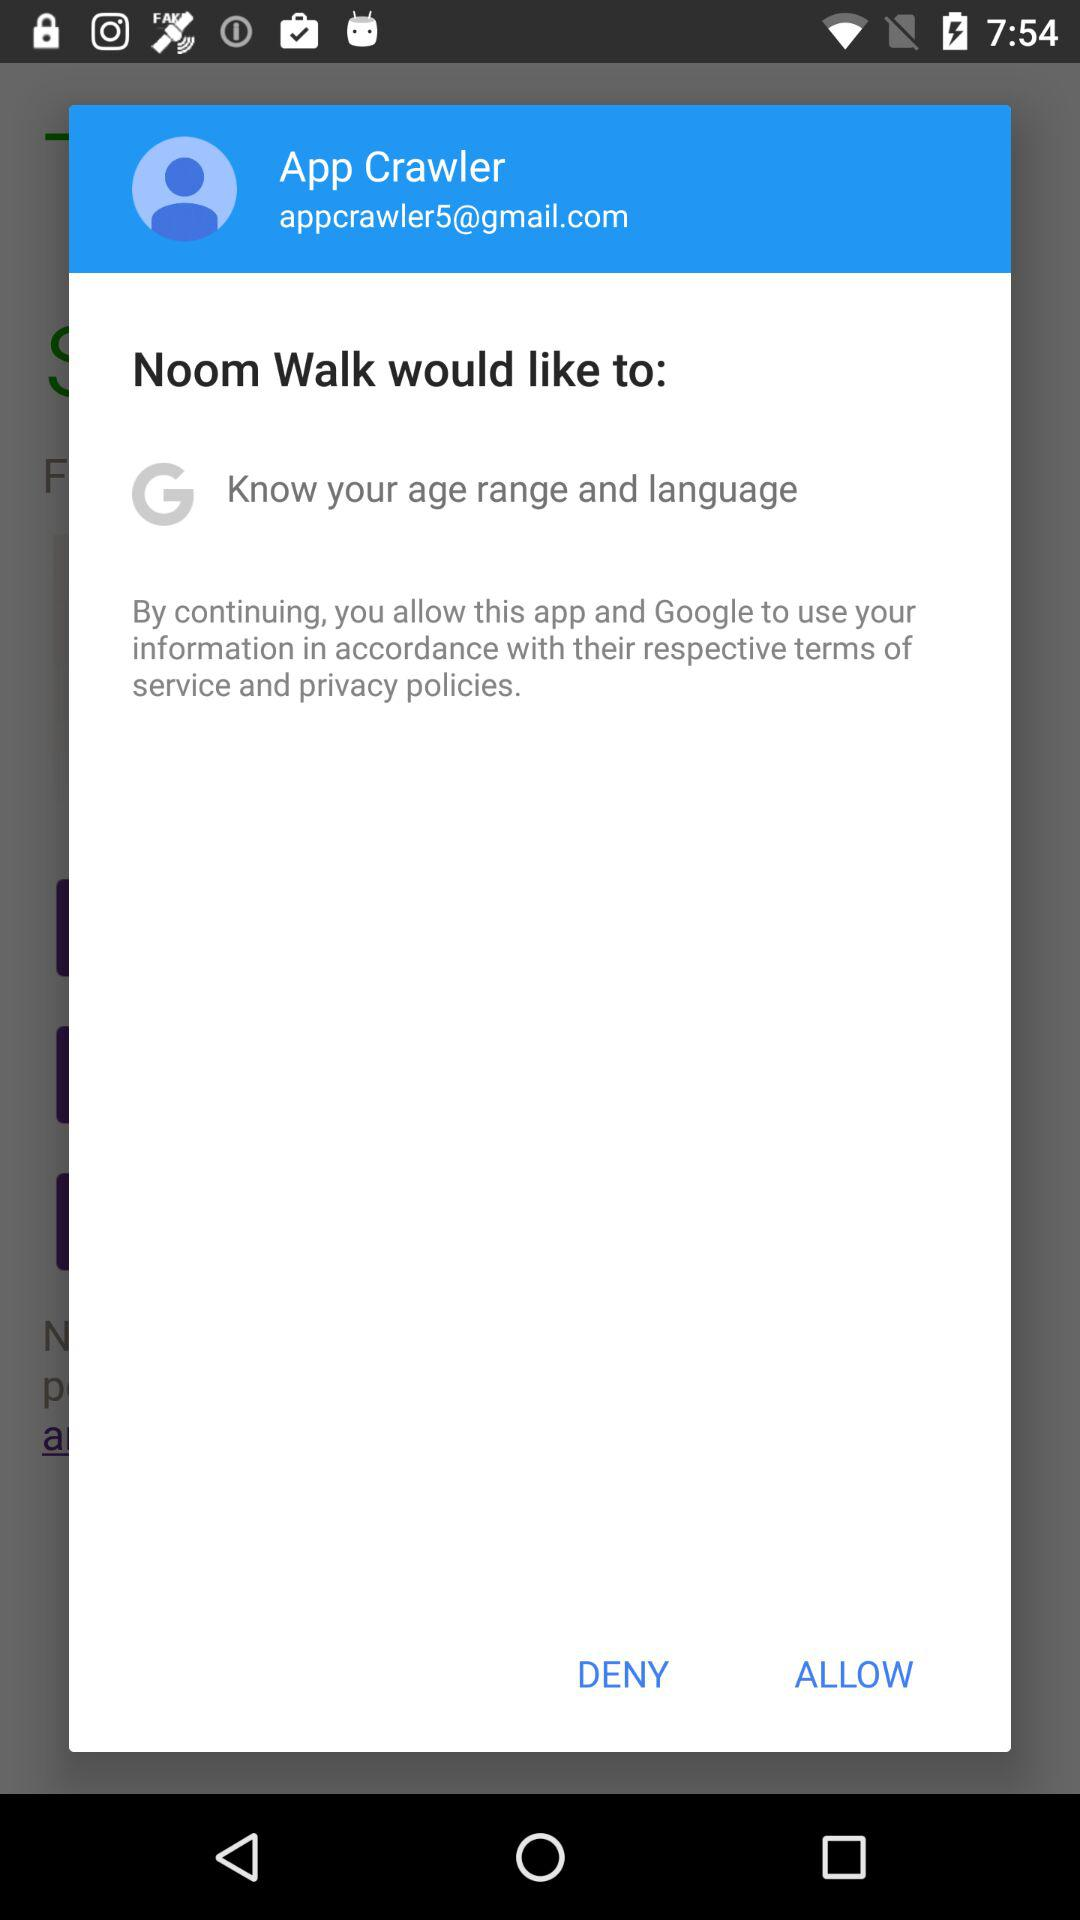What would "Noom Walk" like to do? "Noom Walk" would like to know your age range and language. 